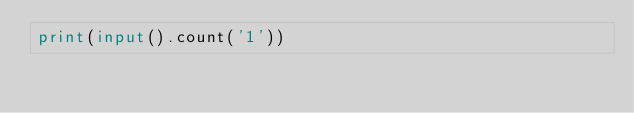<code> <loc_0><loc_0><loc_500><loc_500><_Python_>print(input().count('1'))</code> 